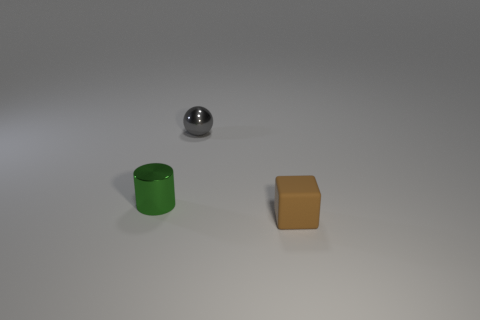Add 3 tiny yellow spheres. How many objects exist? 6 Subtract all cubes. How many objects are left? 2 Subtract 1 balls. How many balls are left? 0 Subtract all cyan cubes. Subtract all gray balls. How many cubes are left? 1 Subtract all brown cubes. How many red cylinders are left? 0 Subtract all small green objects. Subtract all tiny cyan balls. How many objects are left? 2 Add 1 metal objects. How many metal objects are left? 3 Add 1 tiny purple rubber cylinders. How many tiny purple rubber cylinders exist? 1 Subtract 1 green cylinders. How many objects are left? 2 